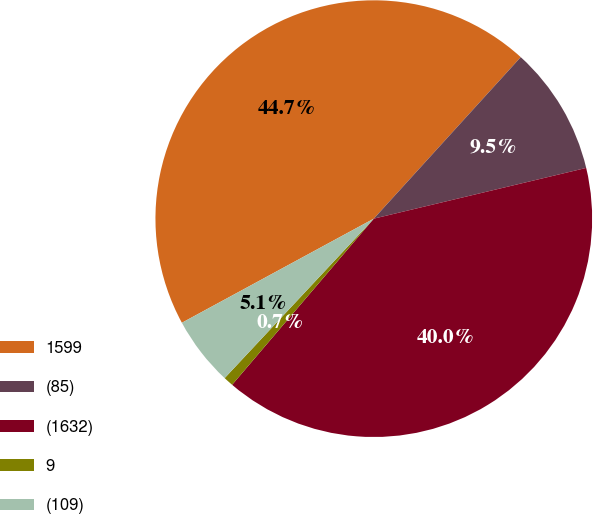Convert chart. <chart><loc_0><loc_0><loc_500><loc_500><pie_chart><fcel>1599<fcel>(85)<fcel>(1632)<fcel>9<fcel>(109)<nl><fcel>44.66%<fcel>9.52%<fcel>39.97%<fcel>0.73%<fcel>5.12%<nl></chart> 